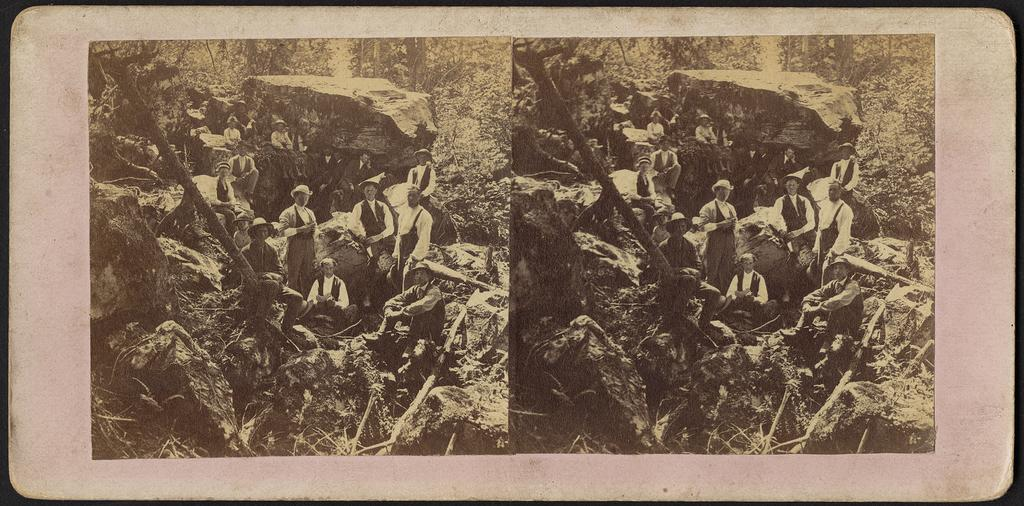How many people are in the image? There is a group of persons standing in the image. What type of natural features can be seen in the image? There are rocks and trees in the image. What is the color scheme of the image? The image is in black and white. What type of education is being discussed by the group of persons in the image? There is no indication in the image that the group of persons is discussing education. 